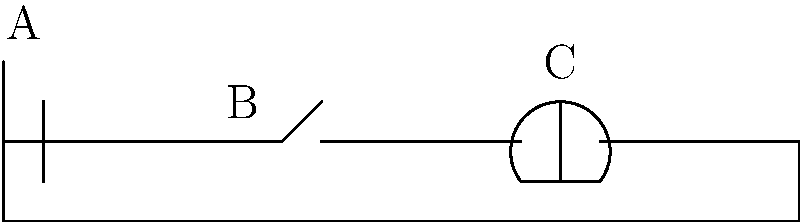In the electrical circuit diagram above, identify the components labeled A, B, and C. Which component represents the battery, switch, and light bulb? To correctly label the parts of this simple electrical circuit diagram, let's analyze each component:

1. Component A:
   - This symbol shows two parallel lines of unequal length.
   - In electrical diagrams, this represents a battery or power source.

2. Component B:
   - This symbol shows a break in the circuit with a small arc.
   - It represents a switch, which can open or close the circuit.

3. Component C:
   - This symbol shows a circle with an 'X' inside.
   - In electrical diagrams, this represents a light bulb or lamp.

Therefore, we can conclude:
- A represents the battery
- B represents the switch
- C represents the light bulb

Understanding these basic symbols is crucial for interpreting and creating educational materials about simple electrical circuits for children.
Answer: A: Battery, B: Switch, C: Light bulb 